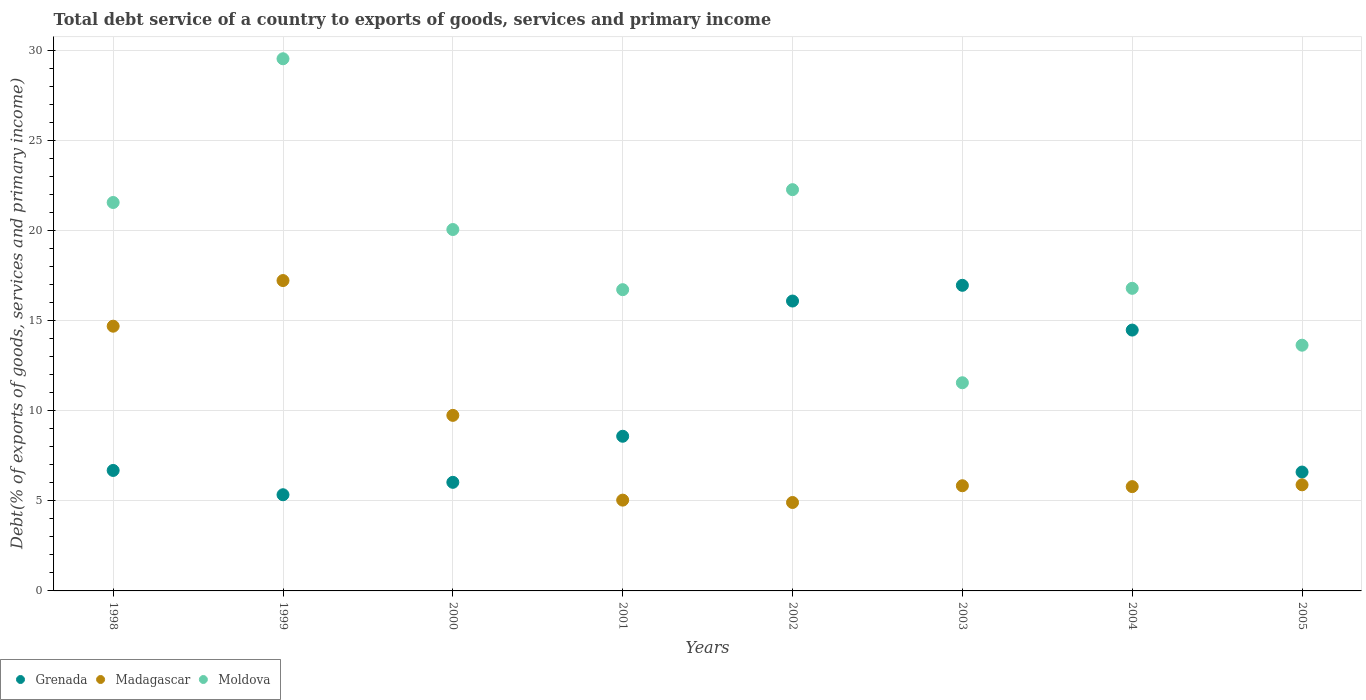How many different coloured dotlines are there?
Make the answer very short. 3. What is the total debt service in Madagascar in 2002?
Offer a very short reply. 4.91. Across all years, what is the maximum total debt service in Madagascar?
Keep it short and to the point. 17.22. Across all years, what is the minimum total debt service in Moldova?
Provide a short and direct response. 11.55. In which year was the total debt service in Moldova maximum?
Keep it short and to the point. 1999. What is the total total debt service in Moldova in the graph?
Your answer should be very brief. 152.04. What is the difference between the total debt service in Grenada in 2001 and that in 2004?
Provide a succinct answer. -5.89. What is the difference between the total debt service in Moldova in 2004 and the total debt service in Grenada in 2002?
Your answer should be compact. 0.7. What is the average total debt service in Grenada per year?
Your answer should be very brief. 10.09. In the year 2002, what is the difference between the total debt service in Moldova and total debt service in Madagascar?
Provide a succinct answer. 17.35. In how many years, is the total debt service in Moldova greater than 6 %?
Your answer should be compact. 8. What is the ratio of the total debt service in Madagascar in 2002 to that in 2003?
Provide a succinct answer. 0.84. What is the difference between the highest and the second highest total debt service in Grenada?
Provide a succinct answer. 0.87. What is the difference between the highest and the lowest total debt service in Moldova?
Provide a succinct answer. 17.97. In how many years, is the total debt service in Madagascar greater than the average total debt service in Madagascar taken over all years?
Keep it short and to the point. 3. Is the sum of the total debt service in Madagascar in 2001 and 2004 greater than the maximum total debt service in Moldova across all years?
Provide a short and direct response. No. Is it the case that in every year, the sum of the total debt service in Madagascar and total debt service in Moldova  is greater than the total debt service in Grenada?
Your answer should be very brief. Yes. Is the total debt service in Madagascar strictly less than the total debt service in Grenada over the years?
Ensure brevity in your answer.  No. What is the difference between two consecutive major ticks on the Y-axis?
Ensure brevity in your answer.  5. Does the graph contain any zero values?
Make the answer very short. No. Where does the legend appear in the graph?
Your answer should be compact. Bottom left. How many legend labels are there?
Give a very brief answer. 3. What is the title of the graph?
Your answer should be very brief. Total debt service of a country to exports of goods, services and primary income. Does "Saudi Arabia" appear as one of the legend labels in the graph?
Offer a terse response. No. What is the label or title of the Y-axis?
Provide a succinct answer. Debt(% of exports of goods, services and primary income). What is the Debt(% of exports of goods, services and primary income) of Grenada in 1998?
Your answer should be compact. 6.68. What is the Debt(% of exports of goods, services and primary income) in Madagascar in 1998?
Make the answer very short. 14.68. What is the Debt(% of exports of goods, services and primary income) of Moldova in 1998?
Provide a succinct answer. 21.55. What is the Debt(% of exports of goods, services and primary income) in Grenada in 1999?
Keep it short and to the point. 5.33. What is the Debt(% of exports of goods, services and primary income) of Madagascar in 1999?
Your response must be concise. 17.22. What is the Debt(% of exports of goods, services and primary income) in Moldova in 1999?
Provide a succinct answer. 29.52. What is the Debt(% of exports of goods, services and primary income) in Grenada in 2000?
Provide a succinct answer. 6.02. What is the Debt(% of exports of goods, services and primary income) of Madagascar in 2000?
Your answer should be very brief. 9.74. What is the Debt(% of exports of goods, services and primary income) in Moldova in 2000?
Your response must be concise. 20.05. What is the Debt(% of exports of goods, services and primary income) in Grenada in 2001?
Offer a very short reply. 8.58. What is the Debt(% of exports of goods, services and primary income) of Madagascar in 2001?
Give a very brief answer. 5.04. What is the Debt(% of exports of goods, services and primary income) in Moldova in 2001?
Your response must be concise. 16.71. What is the Debt(% of exports of goods, services and primary income) in Grenada in 2002?
Provide a succinct answer. 16.08. What is the Debt(% of exports of goods, services and primary income) of Madagascar in 2002?
Your answer should be very brief. 4.91. What is the Debt(% of exports of goods, services and primary income) in Moldova in 2002?
Provide a short and direct response. 22.26. What is the Debt(% of exports of goods, services and primary income) in Grenada in 2003?
Give a very brief answer. 16.95. What is the Debt(% of exports of goods, services and primary income) of Madagascar in 2003?
Make the answer very short. 5.83. What is the Debt(% of exports of goods, services and primary income) in Moldova in 2003?
Provide a succinct answer. 11.55. What is the Debt(% of exports of goods, services and primary income) of Grenada in 2004?
Your answer should be compact. 14.47. What is the Debt(% of exports of goods, services and primary income) in Madagascar in 2004?
Provide a succinct answer. 5.79. What is the Debt(% of exports of goods, services and primary income) of Moldova in 2004?
Give a very brief answer. 16.79. What is the Debt(% of exports of goods, services and primary income) of Grenada in 2005?
Provide a succinct answer. 6.59. What is the Debt(% of exports of goods, services and primary income) in Madagascar in 2005?
Ensure brevity in your answer.  5.89. What is the Debt(% of exports of goods, services and primary income) in Moldova in 2005?
Ensure brevity in your answer.  13.63. Across all years, what is the maximum Debt(% of exports of goods, services and primary income) of Grenada?
Offer a very short reply. 16.95. Across all years, what is the maximum Debt(% of exports of goods, services and primary income) in Madagascar?
Keep it short and to the point. 17.22. Across all years, what is the maximum Debt(% of exports of goods, services and primary income) in Moldova?
Ensure brevity in your answer.  29.52. Across all years, what is the minimum Debt(% of exports of goods, services and primary income) of Grenada?
Your answer should be very brief. 5.33. Across all years, what is the minimum Debt(% of exports of goods, services and primary income) of Madagascar?
Your answer should be compact. 4.91. Across all years, what is the minimum Debt(% of exports of goods, services and primary income) in Moldova?
Ensure brevity in your answer.  11.55. What is the total Debt(% of exports of goods, services and primary income) in Grenada in the graph?
Give a very brief answer. 80.72. What is the total Debt(% of exports of goods, services and primary income) in Madagascar in the graph?
Your answer should be very brief. 69.09. What is the total Debt(% of exports of goods, services and primary income) of Moldova in the graph?
Offer a very short reply. 152.04. What is the difference between the Debt(% of exports of goods, services and primary income) in Grenada in 1998 and that in 1999?
Give a very brief answer. 1.35. What is the difference between the Debt(% of exports of goods, services and primary income) in Madagascar in 1998 and that in 1999?
Provide a succinct answer. -2.53. What is the difference between the Debt(% of exports of goods, services and primary income) of Moldova in 1998 and that in 1999?
Offer a very short reply. -7.97. What is the difference between the Debt(% of exports of goods, services and primary income) of Grenada in 1998 and that in 2000?
Provide a succinct answer. 0.66. What is the difference between the Debt(% of exports of goods, services and primary income) in Madagascar in 1998 and that in 2000?
Your response must be concise. 4.95. What is the difference between the Debt(% of exports of goods, services and primary income) of Moldova in 1998 and that in 2000?
Give a very brief answer. 1.5. What is the difference between the Debt(% of exports of goods, services and primary income) in Grenada in 1998 and that in 2001?
Keep it short and to the point. -1.9. What is the difference between the Debt(% of exports of goods, services and primary income) in Madagascar in 1998 and that in 2001?
Give a very brief answer. 9.65. What is the difference between the Debt(% of exports of goods, services and primary income) of Moldova in 1998 and that in 2001?
Offer a terse response. 4.84. What is the difference between the Debt(% of exports of goods, services and primary income) in Grenada in 1998 and that in 2002?
Your response must be concise. -9.4. What is the difference between the Debt(% of exports of goods, services and primary income) in Madagascar in 1998 and that in 2002?
Offer a very short reply. 9.78. What is the difference between the Debt(% of exports of goods, services and primary income) in Moldova in 1998 and that in 2002?
Ensure brevity in your answer.  -0.71. What is the difference between the Debt(% of exports of goods, services and primary income) in Grenada in 1998 and that in 2003?
Your answer should be compact. -10.27. What is the difference between the Debt(% of exports of goods, services and primary income) of Madagascar in 1998 and that in 2003?
Your response must be concise. 8.85. What is the difference between the Debt(% of exports of goods, services and primary income) of Moldova in 1998 and that in 2003?
Your answer should be very brief. 10. What is the difference between the Debt(% of exports of goods, services and primary income) in Grenada in 1998 and that in 2004?
Offer a terse response. -7.79. What is the difference between the Debt(% of exports of goods, services and primary income) in Madagascar in 1998 and that in 2004?
Keep it short and to the point. 8.9. What is the difference between the Debt(% of exports of goods, services and primary income) of Moldova in 1998 and that in 2004?
Your answer should be compact. 4.76. What is the difference between the Debt(% of exports of goods, services and primary income) in Grenada in 1998 and that in 2005?
Your answer should be compact. 0.09. What is the difference between the Debt(% of exports of goods, services and primary income) of Madagascar in 1998 and that in 2005?
Make the answer very short. 8.8. What is the difference between the Debt(% of exports of goods, services and primary income) in Moldova in 1998 and that in 2005?
Your answer should be very brief. 7.92. What is the difference between the Debt(% of exports of goods, services and primary income) of Grenada in 1999 and that in 2000?
Ensure brevity in your answer.  -0.69. What is the difference between the Debt(% of exports of goods, services and primary income) in Madagascar in 1999 and that in 2000?
Make the answer very short. 7.48. What is the difference between the Debt(% of exports of goods, services and primary income) in Moldova in 1999 and that in 2000?
Give a very brief answer. 9.47. What is the difference between the Debt(% of exports of goods, services and primary income) of Grenada in 1999 and that in 2001?
Ensure brevity in your answer.  -3.24. What is the difference between the Debt(% of exports of goods, services and primary income) in Madagascar in 1999 and that in 2001?
Provide a short and direct response. 12.18. What is the difference between the Debt(% of exports of goods, services and primary income) in Moldova in 1999 and that in 2001?
Offer a terse response. 12.81. What is the difference between the Debt(% of exports of goods, services and primary income) in Grenada in 1999 and that in 2002?
Your response must be concise. -10.75. What is the difference between the Debt(% of exports of goods, services and primary income) in Madagascar in 1999 and that in 2002?
Your response must be concise. 12.31. What is the difference between the Debt(% of exports of goods, services and primary income) in Moldova in 1999 and that in 2002?
Ensure brevity in your answer.  7.26. What is the difference between the Debt(% of exports of goods, services and primary income) in Grenada in 1999 and that in 2003?
Your response must be concise. -11.62. What is the difference between the Debt(% of exports of goods, services and primary income) of Madagascar in 1999 and that in 2003?
Make the answer very short. 11.38. What is the difference between the Debt(% of exports of goods, services and primary income) in Moldova in 1999 and that in 2003?
Offer a terse response. 17.97. What is the difference between the Debt(% of exports of goods, services and primary income) in Grenada in 1999 and that in 2004?
Keep it short and to the point. -9.13. What is the difference between the Debt(% of exports of goods, services and primary income) in Madagascar in 1999 and that in 2004?
Offer a terse response. 11.43. What is the difference between the Debt(% of exports of goods, services and primary income) of Moldova in 1999 and that in 2004?
Ensure brevity in your answer.  12.73. What is the difference between the Debt(% of exports of goods, services and primary income) in Grenada in 1999 and that in 2005?
Provide a short and direct response. -1.26. What is the difference between the Debt(% of exports of goods, services and primary income) in Madagascar in 1999 and that in 2005?
Your answer should be compact. 11.33. What is the difference between the Debt(% of exports of goods, services and primary income) in Moldova in 1999 and that in 2005?
Provide a short and direct response. 15.89. What is the difference between the Debt(% of exports of goods, services and primary income) of Grenada in 2000 and that in 2001?
Keep it short and to the point. -2.56. What is the difference between the Debt(% of exports of goods, services and primary income) in Madagascar in 2000 and that in 2001?
Give a very brief answer. 4.7. What is the difference between the Debt(% of exports of goods, services and primary income) of Moldova in 2000 and that in 2001?
Your answer should be very brief. 3.34. What is the difference between the Debt(% of exports of goods, services and primary income) in Grenada in 2000 and that in 2002?
Give a very brief answer. -10.06. What is the difference between the Debt(% of exports of goods, services and primary income) of Madagascar in 2000 and that in 2002?
Make the answer very short. 4.83. What is the difference between the Debt(% of exports of goods, services and primary income) in Moldova in 2000 and that in 2002?
Keep it short and to the point. -2.21. What is the difference between the Debt(% of exports of goods, services and primary income) of Grenada in 2000 and that in 2003?
Provide a succinct answer. -10.93. What is the difference between the Debt(% of exports of goods, services and primary income) in Madagascar in 2000 and that in 2003?
Your response must be concise. 3.9. What is the difference between the Debt(% of exports of goods, services and primary income) of Moldova in 2000 and that in 2003?
Provide a short and direct response. 8.5. What is the difference between the Debt(% of exports of goods, services and primary income) of Grenada in 2000 and that in 2004?
Your response must be concise. -8.45. What is the difference between the Debt(% of exports of goods, services and primary income) in Madagascar in 2000 and that in 2004?
Ensure brevity in your answer.  3.95. What is the difference between the Debt(% of exports of goods, services and primary income) of Moldova in 2000 and that in 2004?
Offer a very short reply. 3.26. What is the difference between the Debt(% of exports of goods, services and primary income) of Grenada in 2000 and that in 2005?
Ensure brevity in your answer.  -0.57. What is the difference between the Debt(% of exports of goods, services and primary income) of Madagascar in 2000 and that in 2005?
Your answer should be very brief. 3.85. What is the difference between the Debt(% of exports of goods, services and primary income) of Moldova in 2000 and that in 2005?
Keep it short and to the point. 6.42. What is the difference between the Debt(% of exports of goods, services and primary income) in Grenada in 2001 and that in 2002?
Make the answer very short. -7.5. What is the difference between the Debt(% of exports of goods, services and primary income) of Madagascar in 2001 and that in 2002?
Your response must be concise. 0.13. What is the difference between the Debt(% of exports of goods, services and primary income) of Moldova in 2001 and that in 2002?
Your response must be concise. -5.55. What is the difference between the Debt(% of exports of goods, services and primary income) of Grenada in 2001 and that in 2003?
Make the answer very short. -8.37. What is the difference between the Debt(% of exports of goods, services and primary income) in Madagascar in 2001 and that in 2003?
Your answer should be compact. -0.8. What is the difference between the Debt(% of exports of goods, services and primary income) of Moldova in 2001 and that in 2003?
Keep it short and to the point. 5.16. What is the difference between the Debt(% of exports of goods, services and primary income) of Grenada in 2001 and that in 2004?
Offer a terse response. -5.89. What is the difference between the Debt(% of exports of goods, services and primary income) of Madagascar in 2001 and that in 2004?
Keep it short and to the point. -0.75. What is the difference between the Debt(% of exports of goods, services and primary income) in Moldova in 2001 and that in 2004?
Provide a short and direct response. -0.07. What is the difference between the Debt(% of exports of goods, services and primary income) in Grenada in 2001 and that in 2005?
Give a very brief answer. 1.99. What is the difference between the Debt(% of exports of goods, services and primary income) in Madagascar in 2001 and that in 2005?
Your response must be concise. -0.85. What is the difference between the Debt(% of exports of goods, services and primary income) in Moldova in 2001 and that in 2005?
Provide a short and direct response. 3.08. What is the difference between the Debt(% of exports of goods, services and primary income) of Grenada in 2002 and that in 2003?
Provide a succinct answer. -0.87. What is the difference between the Debt(% of exports of goods, services and primary income) of Madagascar in 2002 and that in 2003?
Your response must be concise. -0.93. What is the difference between the Debt(% of exports of goods, services and primary income) in Moldova in 2002 and that in 2003?
Give a very brief answer. 10.71. What is the difference between the Debt(% of exports of goods, services and primary income) of Grenada in 2002 and that in 2004?
Keep it short and to the point. 1.61. What is the difference between the Debt(% of exports of goods, services and primary income) in Madagascar in 2002 and that in 2004?
Provide a succinct answer. -0.88. What is the difference between the Debt(% of exports of goods, services and primary income) in Moldova in 2002 and that in 2004?
Your answer should be compact. 5.47. What is the difference between the Debt(% of exports of goods, services and primary income) in Grenada in 2002 and that in 2005?
Your answer should be compact. 9.49. What is the difference between the Debt(% of exports of goods, services and primary income) of Madagascar in 2002 and that in 2005?
Provide a succinct answer. -0.98. What is the difference between the Debt(% of exports of goods, services and primary income) in Moldova in 2002 and that in 2005?
Provide a succinct answer. 8.63. What is the difference between the Debt(% of exports of goods, services and primary income) in Grenada in 2003 and that in 2004?
Offer a terse response. 2.48. What is the difference between the Debt(% of exports of goods, services and primary income) in Madagascar in 2003 and that in 2004?
Provide a succinct answer. 0.05. What is the difference between the Debt(% of exports of goods, services and primary income) of Moldova in 2003 and that in 2004?
Provide a succinct answer. -5.24. What is the difference between the Debt(% of exports of goods, services and primary income) in Grenada in 2003 and that in 2005?
Ensure brevity in your answer.  10.36. What is the difference between the Debt(% of exports of goods, services and primary income) in Madagascar in 2003 and that in 2005?
Your response must be concise. -0.05. What is the difference between the Debt(% of exports of goods, services and primary income) in Moldova in 2003 and that in 2005?
Your answer should be very brief. -2.08. What is the difference between the Debt(% of exports of goods, services and primary income) of Grenada in 2004 and that in 2005?
Your answer should be very brief. 7.88. What is the difference between the Debt(% of exports of goods, services and primary income) of Madagascar in 2004 and that in 2005?
Keep it short and to the point. -0.1. What is the difference between the Debt(% of exports of goods, services and primary income) of Moldova in 2004 and that in 2005?
Your answer should be very brief. 3.15. What is the difference between the Debt(% of exports of goods, services and primary income) in Grenada in 1998 and the Debt(% of exports of goods, services and primary income) in Madagascar in 1999?
Offer a very short reply. -10.53. What is the difference between the Debt(% of exports of goods, services and primary income) of Grenada in 1998 and the Debt(% of exports of goods, services and primary income) of Moldova in 1999?
Keep it short and to the point. -22.84. What is the difference between the Debt(% of exports of goods, services and primary income) in Madagascar in 1998 and the Debt(% of exports of goods, services and primary income) in Moldova in 1999?
Provide a short and direct response. -14.83. What is the difference between the Debt(% of exports of goods, services and primary income) in Grenada in 1998 and the Debt(% of exports of goods, services and primary income) in Madagascar in 2000?
Your response must be concise. -3.06. What is the difference between the Debt(% of exports of goods, services and primary income) in Grenada in 1998 and the Debt(% of exports of goods, services and primary income) in Moldova in 2000?
Ensure brevity in your answer.  -13.36. What is the difference between the Debt(% of exports of goods, services and primary income) in Madagascar in 1998 and the Debt(% of exports of goods, services and primary income) in Moldova in 2000?
Ensure brevity in your answer.  -5.36. What is the difference between the Debt(% of exports of goods, services and primary income) in Grenada in 1998 and the Debt(% of exports of goods, services and primary income) in Madagascar in 2001?
Keep it short and to the point. 1.65. What is the difference between the Debt(% of exports of goods, services and primary income) in Grenada in 1998 and the Debt(% of exports of goods, services and primary income) in Moldova in 2001?
Provide a succinct answer. -10.03. What is the difference between the Debt(% of exports of goods, services and primary income) of Madagascar in 1998 and the Debt(% of exports of goods, services and primary income) of Moldova in 2001?
Offer a terse response. -2.03. What is the difference between the Debt(% of exports of goods, services and primary income) of Grenada in 1998 and the Debt(% of exports of goods, services and primary income) of Madagascar in 2002?
Give a very brief answer. 1.78. What is the difference between the Debt(% of exports of goods, services and primary income) of Grenada in 1998 and the Debt(% of exports of goods, services and primary income) of Moldova in 2002?
Keep it short and to the point. -15.57. What is the difference between the Debt(% of exports of goods, services and primary income) in Madagascar in 1998 and the Debt(% of exports of goods, services and primary income) in Moldova in 2002?
Offer a very short reply. -7.57. What is the difference between the Debt(% of exports of goods, services and primary income) in Grenada in 1998 and the Debt(% of exports of goods, services and primary income) in Madagascar in 2003?
Keep it short and to the point. 0.85. What is the difference between the Debt(% of exports of goods, services and primary income) of Grenada in 1998 and the Debt(% of exports of goods, services and primary income) of Moldova in 2003?
Provide a short and direct response. -4.86. What is the difference between the Debt(% of exports of goods, services and primary income) in Madagascar in 1998 and the Debt(% of exports of goods, services and primary income) in Moldova in 2003?
Provide a short and direct response. 3.14. What is the difference between the Debt(% of exports of goods, services and primary income) of Grenada in 1998 and the Debt(% of exports of goods, services and primary income) of Madagascar in 2004?
Make the answer very short. 0.9. What is the difference between the Debt(% of exports of goods, services and primary income) in Grenada in 1998 and the Debt(% of exports of goods, services and primary income) in Moldova in 2004?
Make the answer very short. -10.1. What is the difference between the Debt(% of exports of goods, services and primary income) in Madagascar in 1998 and the Debt(% of exports of goods, services and primary income) in Moldova in 2004?
Offer a terse response. -2.1. What is the difference between the Debt(% of exports of goods, services and primary income) in Grenada in 1998 and the Debt(% of exports of goods, services and primary income) in Madagascar in 2005?
Make the answer very short. 0.8. What is the difference between the Debt(% of exports of goods, services and primary income) of Grenada in 1998 and the Debt(% of exports of goods, services and primary income) of Moldova in 2005?
Ensure brevity in your answer.  -6.95. What is the difference between the Debt(% of exports of goods, services and primary income) in Madagascar in 1998 and the Debt(% of exports of goods, services and primary income) in Moldova in 2005?
Keep it short and to the point. 1.05. What is the difference between the Debt(% of exports of goods, services and primary income) of Grenada in 1999 and the Debt(% of exports of goods, services and primary income) of Madagascar in 2000?
Keep it short and to the point. -4.4. What is the difference between the Debt(% of exports of goods, services and primary income) in Grenada in 1999 and the Debt(% of exports of goods, services and primary income) in Moldova in 2000?
Give a very brief answer. -14.71. What is the difference between the Debt(% of exports of goods, services and primary income) in Madagascar in 1999 and the Debt(% of exports of goods, services and primary income) in Moldova in 2000?
Make the answer very short. -2.83. What is the difference between the Debt(% of exports of goods, services and primary income) in Grenada in 1999 and the Debt(% of exports of goods, services and primary income) in Madagascar in 2001?
Provide a short and direct response. 0.3. What is the difference between the Debt(% of exports of goods, services and primary income) of Grenada in 1999 and the Debt(% of exports of goods, services and primary income) of Moldova in 2001?
Offer a very short reply. -11.38. What is the difference between the Debt(% of exports of goods, services and primary income) in Madagascar in 1999 and the Debt(% of exports of goods, services and primary income) in Moldova in 2001?
Provide a short and direct response. 0.51. What is the difference between the Debt(% of exports of goods, services and primary income) of Grenada in 1999 and the Debt(% of exports of goods, services and primary income) of Madagascar in 2002?
Make the answer very short. 0.43. What is the difference between the Debt(% of exports of goods, services and primary income) of Grenada in 1999 and the Debt(% of exports of goods, services and primary income) of Moldova in 2002?
Your answer should be very brief. -16.92. What is the difference between the Debt(% of exports of goods, services and primary income) in Madagascar in 1999 and the Debt(% of exports of goods, services and primary income) in Moldova in 2002?
Your response must be concise. -5.04. What is the difference between the Debt(% of exports of goods, services and primary income) in Grenada in 1999 and the Debt(% of exports of goods, services and primary income) in Madagascar in 2003?
Ensure brevity in your answer.  -0.5. What is the difference between the Debt(% of exports of goods, services and primary income) in Grenada in 1999 and the Debt(% of exports of goods, services and primary income) in Moldova in 2003?
Offer a terse response. -6.21. What is the difference between the Debt(% of exports of goods, services and primary income) of Madagascar in 1999 and the Debt(% of exports of goods, services and primary income) of Moldova in 2003?
Ensure brevity in your answer.  5.67. What is the difference between the Debt(% of exports of goods, services and primary income) in Grenada in 1999 and the Debt(% of exports of goods, services and primary income) in Madagascar in 2004?
Provide a succinct answer. -0.45. What is the difference between the Debt(% of exports of goods, services and primary income) of Grenada in 1999 and the Debt(% of exports of goods, services and primary income) of Moldova in 2004?
Your answer should be compact. -11.45. What is the difference between the Debt(% of exports of goods, services and primary income) in Madagascar in 1999 and the Debt(% of exports of goods, services and primary income) in Moldova in 2004?
Give a very brief answer. 0.43. What is the difference between the Debt(% of exports of goods, services and primary income) of Grenada in 1999 and the Debt(% of exports of goods, services and primary income) of Madagascar in 2005?
Offer a very short reply. -0.55. What is the difference between the Debt(% of exports of goods, services and primary income) of Grenada in 1999 and the Debt(% of exports of goods, services and primary income) of Moldova in 2005?
Provide a succinct answer. -8.3. What is the difference between the Debt(% of exports of goods, services and primary income) of Madagascar in 1999 and the Debt(% of exports of goods, services and primary income) of Moldova in 2005?
Your response must be concise. 3.59. What is the difference between the Debt(% of exports of goods, services and primary income) of Grenada in 2000 and the Debt(% of exports of goods, services and primary income) of Madagascar in 2001?
Provide a short and direct response. 0.99. What is the difference between the Debt(% of exports of goods, services and primary income) of Grenada in 2000 and the Debt(% of exports of goods, services and primary income) of Moldova in 2001?
Your response must be concise. -10.69. What is the difference between the Debt(% of exports of goods, services and primary income) in Madagascar in 2000 and the Debt(% of exports of goods, services and primary income) in Moldova in 2001?
Offer a terse response. -6.97. What is the difference between the Debt(% of exports of goods, services and primary income) in Grenada in 2000 and the Debt(% of exports of goods, services and primary income) in Madagascar in 2002?
Offer a very short reply. 1.12. What is the difference between the Debt(% of exports of goods, services and primary income) in Grenada in 2000 and the Debt(% of exports of goods, services and primary income) in Moldova in 2002?
Make the answer very short. -16.23. What is the difference between the Debt(% of exports of goods, services and primary income) of Madagascar in 2000 and the Debt(% of exports of goods, services and primary income) of Moldova in 2002?
Offer a terse response. -12.52. What is the difference between the Debt(% of exports of goods, services and primary income) in Grenada in 2000 and the Debt(% of exports of goods, services and primary income) in Madagascar in 2003?
Keep it short and to the point. 0.19. What is the difference between the Debt(% of exports of goods, services and primary income) in Grenada in 2000 and the Debt(% of exports of goods, services and primary income) in Moldova in 2003?
Your response must be concise. -5.52. What is the difference between the Debt(% of exports of goods, services and primary income) of Madagascar in 2000 and the Debt(% of exports of goods, services and primary income) of Moldova in 2003?
Give a very brief answer. -1.81. What is the difference between the Debt(% of exports of goods, services and primary income) in Grenada in 2000 and the Debt(% of exports of goods, services and primary income) in Madagascar in 2004?
Your answer should be very brief. 0.24. What is the difference between the Debt(% of exports of goods, services and primary income) in Grenada in 2000 and the Debt(% of exports of goods, services and primary income) in Moldova in 2004?
Ensure brevity in your answer.  -10.76. What is the difference between the Debt(% of exports of goods, services and primary income) of Madagascar in 2000 and the Debt(% of exports of goods, services and primary income) of Moldova in 2004?
Offer a terse response. -7.05. What is the difference between the Debt(% of exports of goods, services and primary income) in Grenada in 2000 and the Debt(% of exports of goods, services and primary income) in Madagascar in 2005?
Offer a terse response. 0.14. What is the difference between the Debt(% of exports of goods, services and primary income) of Grenada in 2000 and the Debt(% of exports of goods, services and primary income) of Moldova in 2005?
Offer a very short reply. -7.61. What is the difference between the Debt(% of exports of goods, services and primary income) in Madagascar in 2000 and the Debt(% of exports of goods, services and primary income) in Moldova in 2005?
Your answer should be compact. -3.89. What is the difference between the Debt(% of exports of goods, services and primary income) in Grenada in 2001 and the Debt(% of exports of goods, services and primary income) in Madagascar in 2002?
Your answer should be compact. 3.67. What is the difference between the Debt(% of exports of goods, services and primary income) in Grenada in 2001 and the Debt(% of exports of goods, services and primary income) in Moldova in 2002?
Give a very brief answer. -13.68. What is the difference between the Debt(% of exports of goods, services and primary income) of Madagascar in 2001 and the Debt(% of exports of goods, services and primary income) of Moldova in 2002?
Ensure brevity in your answer.  -17.22. What is the difference between the Debt(% of exports of goods, services and primary income) in Grenada in 2001 and the Debt(% of exports of goods, services and primary income) in Madagascar in 2003?
Your response must be concise. 2.75. What is the difference between the Debt(% of exports of goods, services and primary income) of Grenada in 2001 and the Debt(% of exports of goods, services and primary income) of Moldova in 2003?
Ensure brevity in your answer.  -2.97. What is the difference between the Debt(% of exports of goods, services and primary income) in Madagascar in 2001 and the Debt(% of exports of goods, services and primary income) in Moldova in 2003?
Give a very brief answer. -6.51. What is the difference between the Debt(% of exports of goods, services and primary income) in Grenada in 2001 and the Debt(% of exports of goods, services and primary income) in Madagascar in 2004?
Make the answer very short. 2.79. What is the difference between the Debt(% of exports of goods, services and primary income) in Grenada in 2001 and the Debt(% of exports of goods, services and primary income) in Moldova in 2004?
Offer a very short reply. -8.21. What is the difference between the Debt(% of exports of goods, services and primary income) of Madagascar in 2001 and the Debt(% of exports of goods, services and primary income) of Moldova in 2004?
Offer a terse response. -11.75. What is the difference between the Debt(% of exports of goods, services and primary income) in Grenada in 2001 and the Debt(% of exports of goods, services and primary income) in Madagascar in 2005?
Offer a very short reply. 2.69. What is the difference between the Debt(% of exports of goods, services and primary income) in Grenada in 2001 and the Debt(% of exports of goods, services and primary income) in Moldova in 2005?
Keep it short and to the point. -5.05. What is the difference between the Debt(% of exports of goods, services and primary income) of Madagascar in 2001 and the Debt(% of exports of goods, services and primary income) of Moldova in 2005?
Provide a succinct answer. -8.59. What is the difference between the Debt(% of exports of goods, services and primary income) of Grenada in 2002 and the Debt(% of exports of goods, services and primary income) of Madagascar in 2003?
Offer a very short reply. 10.25. What is the difference between the Debt(% of exports of goods, services and primary income) of Grenada in 2002 and the Debt(% of exports of goods, services and primary income) of Moldova in 2003?
Your answer should be very brief. 4.53. What is the difference between the Debt(% of exports of goods, services and primary income) in Madagascar in 2002 and the Debt(% of exports of goods, services and primary income) in Moldova in 2003?
Make the answer very short. -6.64. What is the difference between the Debt(% of exports of goods, services and primary income) of Grenada in 2002 and the Debt(% of exports of goods, services and primary income) of Madagascar in 2004?
Make the answer very short. 10.29. What is the difference between the Debt(% of exports of goods, services and primary income) in Grenada in 2002 and the Debt(% of exports of goods, services and primary income) in Moldova in 2004?
Give a very brief answer. -0.7. What is the difference between the Debt(% of exports of goods, services and primary income) in Madagascar in 2002 and the Debt(% of exports of goods, services and primary income) in Moldova in 2004?
Your response must be concise. -11.88. What is the difference between the Debt(% of exports of goods, services and primary income) of Grenada in 2002 and the Debt(% of exports of goods, services and primary income) of Madagascar in 2005?
Your answer should be very brief. 10.2. What is the difference between the Debt(% of exports of goods, services and primary income) in Grenada in 2002 and the Debt(% of exports of goods, services and primary income) in Moldova in 2005?
Ensure brevity in your answer.  2.45. What is the difference between the Debt(% of exports of goods, services and primary income) in Madagascar in 2002 and the Debt(% of exports of goods, services and primary income) in Moldova in 2005?
Offer a terse response. -8.73. What is the difference between the Debt(% of exports of goods, services and primary income) in Grenada in 2003 and the Debt(% of exports of goods, services and primary income) in Madagascar in 2004?
Provide a succinct answer. 11.17. What is the difference between the Debt(% of exports of goods, services and primary income) in Grenada in 2003 and the Debt(% of exports of goods, services and primary income) in Moldova in 2004?
Your answer should be very brief. 0.17. What is the difference between the Debt(% of exports of goods, services and primary income) in Madagascar in 2003 and the Debt(% of exports of goods, services and primary income) in Moldova in 2004?
Keep it short and to the point. -10.95. What is the difference between the Debt(% of exports of goods, services and primary income) in Grenada in 2003 and the Debt(% of exports of goods, services and primary income) in Madagascar in 2005?
Ensure brevity in your answer.  11.07. What is the difference between the Debt(% of exports of goods, services and primary income) in Grenada in 2003 and the Debt(% of exports of goods, services and primary income) in Moldova in 2005?
Your response must be concise. 3.32. What is the difference between the Debt(% of exports of goods, services and primary income) of Madagascar in 2003 and the Debt(% of exports of goods, services and primary income) of Moldova in 2005?
Ensure brevity in your answer.  -7.8. What is the difference between the Debt(% of exports of goods, services and primary income) of Grenada in 2004 and the Debt(% of exports of goods, services and primary income) of Madagascar in 2005?
Ensure brevity in your answer.  8.58. What is the difference between the Debt(% of exports of goods, services and primary income) in Grenada in 2004 and the Debt(% of exports of goods, services and primary income) in Moldova in 2005?
Offer a very short reply. 0.84. What is the difference between the Debt(% of exports of goods, services and primary income) in Madagascar in 2004 and the Debt(% of exports of goods, services and primary income) in Moldova in 2005?
Ensure brevity in your answer.  -7.85. What is the average Debt(% of exports of goods, services and primary income) in Grenada per year?
Provide a succinct answer. 10.09. What is the average Debt(% of exports of goods, services and primary income) in Madagascar per year?
Make the answer very short. 8.64. What is the average Debt(% of exports of goods, services and primary income) of Moldova per year?
Provide a succinct answer. 19.01. In the year 1998, what is the difference between the Debt(% of exports of goods, services and primary income) of Grenada and Debt(% of exports of goods, services and primary income) of Madagascar?
Offer a terse response. -8. In the year 1998, what is the difference between the Debt(% of exports of goods, services and primary income) in Grenada and Debt(% of exports of goods, services and primary income) in Moldova?
Offer a terse response. -14.86. In the year 1998, what is the difference between the Debt(% of exports of goods, services and primary income) of Madagascar and Debt(% of exports of goods, services and primary income) of Moldova?
Ensure brevity in your answer.  -6.86. In the year 1999, what is the difference between the Debt(% of exports of goods, services and primary income) in Grenada and Debt(% of exports of goods, services and primary income) in Madagascar?
Offer a very short reply. -11.88. In the year 1999, what is the difference between the Debt(% of exports of goods, services and primary income) in Grenada and Debt(% of exports of goods, services and primary income) in Moldova?
Provide a short and direct response. -24.18. In the year 1999, what is the difference between the Debt(% of exports of goods, services and primary income) of Madagascar and Debt(% of exports of goods, services and primary income) of Moldova?
Your response must be concise. -12.3. In the year 2000, what is the difference between the Debt(% of exports of goods, services and primary income) of Grenada and Debt(% of exports of goods, services and primary income) of Madagascar?
Ensure brevity in your answer.  -3.71. In the year 2000, what is the difference between the Debt(% of exports of goods, services and primary income) of Grenada and Debt(% of exports of goods, services and primary income) of Moldova?
Keep it short and to the point. -14.02. In the year 2000, what is the difference between the Debt(% of exports of goods, services and primary income) of Madagascar and Debt(% of exports of goods, services and primary income) of Moldova?
Offer a very short reply. -10.31. In the year 2001, what is the difference between the Debt(% of exports of goods, services and primary income) of Grenada and Debt(% of exports of goods, services and primary income) of Madagascar?
Ensure brevity in your answer.  3.54. In the year 2001, what is the difference between the Debt(% of exports of goods, services and primary income) of Grenada and Debt(% of exports of goods, services and primary income) of Moldova?
Give a very brief answer. -8.13. In the year 2001, what is the difference between the Debt(% of exports of goods, services and primary income) in Madagascar and Debt(% of exports of goods, services and primary income) in Moldova?
Your answer should be very brief. -11.67. In the year 2002, what is the difference between the Debt(% of exports of goods, services and primary income) in Grenada and Debt(% of exports of goods, services and primary income) in Madagascar?
Your answer should be very brief. 11.18. In the year 2002, what is the difference between the Debt(% of exports of goods, services and primary income) of Grenada and Debt(% of exports of goods, services and primary income) of Moldova?
Your answer should be very brief. -6.18. In the year 2002, what is the difference between the Debt(% of exports of goods, services and primary income) of Madagascar and Debt(% of exports of goods, services and primary income) of Moldova?
Make the answer very short. -17.35. In the year 2003, what is the difference between the Debt(% of exports of goods, services and primary income) of Grenada and Debt(% of exports of goods, services and primary income) of Madagascar?
Give a very brief answer. 11.12. In the year 2003, what is the difference between the Debt(% of exports of goods, services and primary income) in Grenada and Debt(% of exports of goods, services and primary income) in Moldova?
Offer a terse response. 5.41. In the year 2003, what is the difference between the Debt(% of exports of goods, services and primary income) of Madagascar and Debt(% of exports of goods, services and primary income) of Moldova?
Ensure brevity in your answer.  -5.71. In the year 2004, what is the difference between the Debt(% of exports of goods, services and primary income) of Grenada and Debt(% of exports of goods, services and primary income) of Madagascar?
Provide a short and direct response. 8.68. In the year 2004, what is the difference between the Debt(% of exports of goods, services and primary income) of Grenada and Debt(% of exports of goods, services and primary income) of Moldova?
Offer a very short reply. -2.32. In the year 2004, what is the difference between the Debt(% of exports of goods, services and primary income) of Madagascar and Debt(% of exports of goods, services and primary income) of Moldova?
Provide a short and direct response. -11. In the year 2005, what is the difference between the Debt(% of exports of goods, services and primary income) in Grenada and Debt(% of exports of goods, services and primary income) in Madagascar?
Offer a terse response. 0.71. In the year 2005, what is the difference between the Debt(% of exports of goods, services and primary income) of Grenada and Debt(% of exports of goods, services and primary income) of Moldova?
Your answer should be very brief. -7.04. In the year 2005, what is the difference between the Debt(% of exports of goods, services and primary income) in Madagascar and Debt(% of exports of goods, services and primary income) in Moldova?
Provide a short and direct response. -7.75. What is the ratio of the Debt(% of exports of goods, services and primary income) in Grenada in 1998 to that in 1999?
Your response must be concise. 1.25. What is the ratio of the Debt(% of exports of goods, services and primary income) of Madagascar in 1998 to that in 1999?
Provide a succinct answer. 0.85. What is the ratio of the Debt(% of exports of goods, services and primary income) in Moldova in 1998 to that in 1999?
Make the answer very short. 0.73. What is the ratio of the Debt(% of exports of goods, services and primary income) of Grenada in 1998 to that in 2000?
Provide a short and direct response. 1.11. What is the ratio of the Debt(% of exports of goods, services and primary income) in Madagascar in 1998 to that in 2000?
Offer a terse response. 1.51. What is the ratio of the Debt(% of exports of goods, services and primary income) in Moldova in 1998 to that in 2000?
Provide a short and direct response. 1.07. What is the ratio of the Debt(% of exports of goods, services and primary income) of Grenada in 1998 to that in 2001?
Your answer should be very brief. 0.78. What is the ratio of the Debt(% of exports of goods, services and primary income) of Madagascar in 1998 to that in 2001?
Your response must be concise. 2.92. What is the ratio of the Debt(% of exports of goods, services and primary income) in Moldova in 1998 to that in 2001?
Your answer should be very brief. 1.29. What is the ratio of the Debt(% of exports of goods, services and primary income) of Grenada in 1998 to that in 2002?
Provide a succinct answer. 0.42. What is the ratio of the Debt(% of exports of goods, services and primary income) of Madagascar in 1998 to that in 2002?
Give a very brief answer. 2.99. What is the ratio of the Debt(% of exports of goods, services and primary income) of Grenada in 1998 to that in 2003?
Your response must be concise. 0.39. What is the ratio of the Debt(% of exports of goods, services and primary income) of Madagascar in 1998 to that in 2003?
Make the answer very short. 2.52. What is the ratio of the Debt(% of exports of goods, services and primary income) in Moldova in 1998 to that in 2003?
Offer a terse response. 1.87. What is the ratio of the Debt(% of exports of goods, services and primary income) of Grenada in 1998 to that in 2004?
Keep it short and to the point. 0.46. What is the ratio of the Debt(% of exports of goods, services and primary income) of Madagascar in 1998 to that in 2004?
Offer a terse response. 2.54. What is the ratio of the Debt(% of exports of goods, services and primary income) of Moldova in 1998 to that in 2004?
Offer a terse response. 1.28. What is the ratio of the Debt(% of exports of goods, services and primary income) of Grenada in 1998 to that in 2005?
Your answer should be very brief. 1.01. What is the ratio of the Debt(% of exports of goods, services and primary income) of Madagascar in 1998 to that in 2005?
Keep it short and to the point. 2.5. What is the ratio of the Debt(% of exports of goods, services and primary income) in Moldova in 1998 to that in 2005?
Keep it short and to the point. 1.58. What is the ratio of the Debt(% of exports of goods, services and primary income) of Grenada in 1999 to that in 2000?
Ensure brevity in your answer.  0.89. What is the ratio of the Debt(% of exports of goods, services and primary income) in Madagascar in 1999 to that in 2000?
Provide a short and direct response. 1.77. What is the ratio of the Debt(% of exports of goods, services and primary income) in Moldova in 1999 to that in 2000?
Make the answer very short. 1.47. What is the ratio of the Debt(% of exports of goods, services and primary income) of Grenada in 1999 to that in 2001?
Offer a terse response. 0.62. What is the ratio of the Debt(% of exports of goods, services and primary income) in Madagascar in 1999 to that in 2001?
Ensure brevity in your answer.  3.42. What is the ratio of the Debt(% of exports of goods, services and primary income) of Moldova in 1999 to that in 2001?
Provide a succinct answer. 1.77. What is the ratio of the Debt(% of exports of goods, services and primary income) of Grenada in 1999 to that in 2002?
Ensure brevity in your answer.  0.33. What is the ratio of the Debt(% of exports of goods, services and primary income) of Madagascar in 1999 to that in 2002?
Give a very brief answer. 3.51. What is the ratio of the Debt(% of exports of goods, services and primary income) of Moldova in 1999 to that in 2002?
Keep it short and to the point. 1.33. What is the ratio of the Debt(% of exports of goods, services and primary income) of Grenada in 1999 to that in 2003?
Offer a very short reply. 0.31. What is the ratio of the Debt(% of exports of goods, services and primary income) in Madagascar in 1999 to that in 2003?
Make the answer very short. 2.95. What is the ratio of the Debt(% of exports of goods, services and primary income) of Moldova in 1999 to that in 2003?
Ensure brevity in your answer.  2.56. What is the ratio of the Debt(% of exports of goods, services and primary income) of Grenada in 1999 to that in 2004?
Offer a very short reply. 0.37. What is the ratio of the Debt(% of exports of goods, services and primary income) in Madagascar in 1999 to that in 2004?
Keep it short and to the point. 2.98. What is the ratio of the Debt(% of exports of goods, services and primary income) of Moldova in 1999 to that in 2004?
Offer a very short reply. 1.76. What is the ratio of the Debt(% of exports of goods, services and primary income) in Grenada in 1999 to that in 2005?
Make the answer very short. 0.81. What is the ratio of the Debt(% of exports of goods, services and primary income) in Madagascar in 1999 to that in 2005?
Your answer should be compact. 2.93. What is the ratio of the Debt(% of exports of goods, services and primary income) in Moldova in 1999 to that in 2005?
Your response must be concise. 2.17. What is the ratio of the Debt(% of exports of goods, services and primary income) of Grenada in 2000 to that in 2001?
Provide a succinct answer. 0.7. What is the ratio of the Debt(% of exports of goods, services and primary income) in Madagascar in 2000 to that in 2001?
Keep it short and to the point. 1.93. What is the ratio of the Debt(% of exports of goods, services and primary income) of Moldova in 2000 to that in 2001?
Make the answer very short. 1.2. What is the ratio of the Debt(% of exports of goods, services and primary income) in Grenada in 2000 to that in 2002?
Offer a terse response. 0.37. What is the ratio of the Debt(% of exports of goods, services and primary income) in Madagascar in 2000 to that in 2002?
Your response must be concise. 1.99. What is the ratio of the Debt(% of exports of goods, services and primary income) in Moldova in 2000 to that in 2002?
Provide a short and direct response. 0.9. What is the ratio of the Debt(% of exports of goods, services and primary income) of Grenada in 2000 to that in 2003?
Give a very brief answer. 0.36. What is the ratio of the Debt(% of exports of goods, services and primary income) in Madagascar in 2000 to that in 2003?
Your answer should be very brief. 1.67. What is the ratio of the Debt(% of exports of goods, services and primary income) of Moldova in 2000 to that in 2003?
Ensure brevity in your answer.  1.74. What is the ratio of the Debt(% of exports of goods, services and primary income) in Grenada in 2000 to that in 2004?
Your answer should be compact. 0.42. What is the ratio of the Debt(% of exports of goods, services and primary income) of Madagascar in 2000 to that in 2004?
Keep it short and to the point. 1.68. What is the ratio of the Debt(% of exports of goods, services and primary income) of Moldova in 2000 to that in 2004?
Keep it short and to the point. 1.19. What is the ratio of the Debt(% of exports of goods, services and primary income) in Grenada in 2000 to that in 2005?
Give a very brief answer. 0.91. What is the ratio of the Debt(% of exports of goods, services and primary income) in Madagascar in 2000 to that in 2005?
Offer a very short reply. 1.65. What is the ratio of the Debt(% of exports of goods, services and primary income) in Moldova in 2000 to that in 2005?
Ensure brevity in your answer.  1.47. What is the ratio of the Debt(% of exports of goods, services and primary income) in Grenada in 2001 to that in 2002?
Give a very brief answer. 0.53. What is the ratio of the Debt(% of exports of goods, services and primary income) of Madagascar in 2001 to that in 2002?
Make the answer very short. 1.03. What is the ratio of the Debt(% of exports of goods, services and primary income) in Moldova in 2001 to that in 2002?
Your answer should be very brief. 0.75. What is the ratio of the Debt(% of exports of goods, services and primary income) in Grenada in 2001 to that in 2003?
Your response must be concise. 0.51. What is the ratio of the Debt(% of exports of goods, services and primary income) in Madagascar in 2001 to that in 2003?
Offer a terse response. 0.86. What is the ratio of the Debt(% of exports of goods, services and primary income) in Moldova in 2001 to that in 2003?
Your answer should be compact. 1.45. What is the ratio of the Debt(% of exports of goods, services and primary income) in Grenada in 2001 to that in 2004?
Provide a short and direct response. 0.59. What is the ratio of the Debt(% of exports of goods, services and primary income) of Madagascar in 2001 to that in 2004?
Provide a succinct answer. 0.87. What is the ratio of the Debt(% of exports of goods, services and primary income) of Moldova in 2001 to that in 2004?
Give a very brief answer. 1. What is the ratio of the Debt(% of exports of goods, services and primary income) in Grenada in 2001 to that in 2005?
Offer a very short reply. 1.3. What is the ratio of the Debt(% of exports of goods, services and primary income) in Madagascar in 2001 to that in 2005?
Keep it short and to the point. 0.86. What is the ratio of the Debt(% of exports of goods, services and primary income) in Moldova in 2001 to that in 2005?
Keep it short and to the point. 1.23. What is the ratio of the Debt(% of exports of goods, services and primary income) in Grenada in 2002 to that in 2003?
Your response must be concise. 0.95. What is the ratio of the Debt(% of exports of goods, services and primary income) in Madagascar in 2002 to that in 2003?
Your answer should be compact. 0.84. What is the ratio of the Debt(% of exports of goods, services and primary income) of Moldova in 2002 to that in 2003?
Your response must be concise. 1.93. What is the ratio of the Debt(% of exports of goods, services and primary income) in Grenada in 2002 to that in 2004?
Offer a very short reply. 1.11. What is the ratio of the Debt(% of exports of goods, services and primary income) in Madagascar in 2002 to that in 2004?
Ensure brevity in your answer.  0.85. What is the ratio of the Debt(% of exports of goods, services and primary income) of Moldova in 2002 to that in 2004?
Make the answer very short. 1.33. What is the ratio of the Debt(% of exports of goods, services and primary income) in Grenada in 2002 to that in 2005?
Your response must be concise. 2.44. What is the ratio of the Debt(% of exports of goods, services and primary income) in Madagascar in 2002 to that in 2005?
Keep it short and to the point. 0.83. What is the ratio of the Debt(% of exports of goods, services and primary income) of Moldova in 2002 to that in 2005?
Your answer should be very brief. 1.63. What is the ratio of the Debt(% of exports of goods, services and primary income) of Grenada in 2003 to that in 2004?
Offer a terse response. 1.17. What is the ratio of the Debt(% of exports of goods, services and primary income) of Madagascar in 2003 to that in 2004?
Offer a very short reply. 1.01. What is the ratio of the Debt(% of exports of goods, services and primary income) of Moldova in 2003 to that in 2004?
Provide a short and direct response. 0.69. What is the ratio of the Debt(% of exports of goods, services and primary income) in Grenada in 2003 to that in 2005?
Ensure brevity in your answer.  2.57. What is the ratio of the Debt(% of exports of goods, services and primary income) in Madagascar in 2003 to that in 2005?
Make the answer very short. 0.99. What is the ratio of the Debt(% of exports of goods, services and primary income) in Moldova in 2003 to that in 2005?
Keep it short and to the point. 0.85. What is the ratio of the Debt(% of exports of goods, services and primary income) in Grenada in 2004 to that in 2005?
Keep it short and to the point. 2.19. What is the ratio of the Debt(% of exports of goods, services and primary income) in Moldova in 2004 to that in 2005?
Offer a terse response. 1.23. What is the difference between the highest and the second highest Debt(% of exports of goods, services and primary income) in Grenada?
Ensure brevity in your answer.  0.87. What is the difference between the highest and the second highest Debt(% of exports of goods, services and primary income) in Madagascar?
Keep it short and to the point. 2.53. What is the difference between the highest and the second highest Debt(% of exports of goods, services and primary income) in Moldova?
Make the answer very short. 7.26. What is the difference between the highest and the lowest Debt(% of exports of goods, services and primary income) in Grenada?
Keep it short and to the point. 11.62. What is the difference between the highest and the lowest Debt(% of exports of goods, services and primary income) of Madagascar?
Give a very brief answer. 12.31. What is the difference between the highest and the lowest Debt(% of exports of goods, services and primary income) in Moldova?
Ensure brevity in your answer.  17.97. 